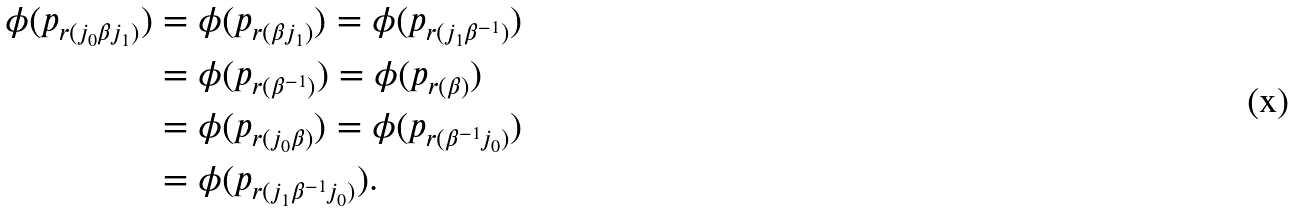Convert formula to latex. <formula><loc_0><loc_0><loc_500><loc_500>\phi ( p _ { r ( j _ { 0 } \beta j _ { 1 } ) } ) & = \phi ( p _ { r ( \beta j _ { 1 } ) } ) = \phi ( p _ { r ( j _ { 1 } \beta ^ { - 1 } ) } ) \\ & = \phi ( p _ { r ( \beta ^ { - 1 } ) } ) = \phi ( p _ { r ( \beta ) } ) \\ & = \phi ( p _ { r ( j _ { 0 } \beta ) } ) = \phi ( p _ { r ( \beta ^ { - 1 } j _ { 0 } ) } ) \\ & = \phi ( p _ { r ( j _ { 1 } \beta ^ { - 1 } j _ { 0 } ) } ) .</formula> 